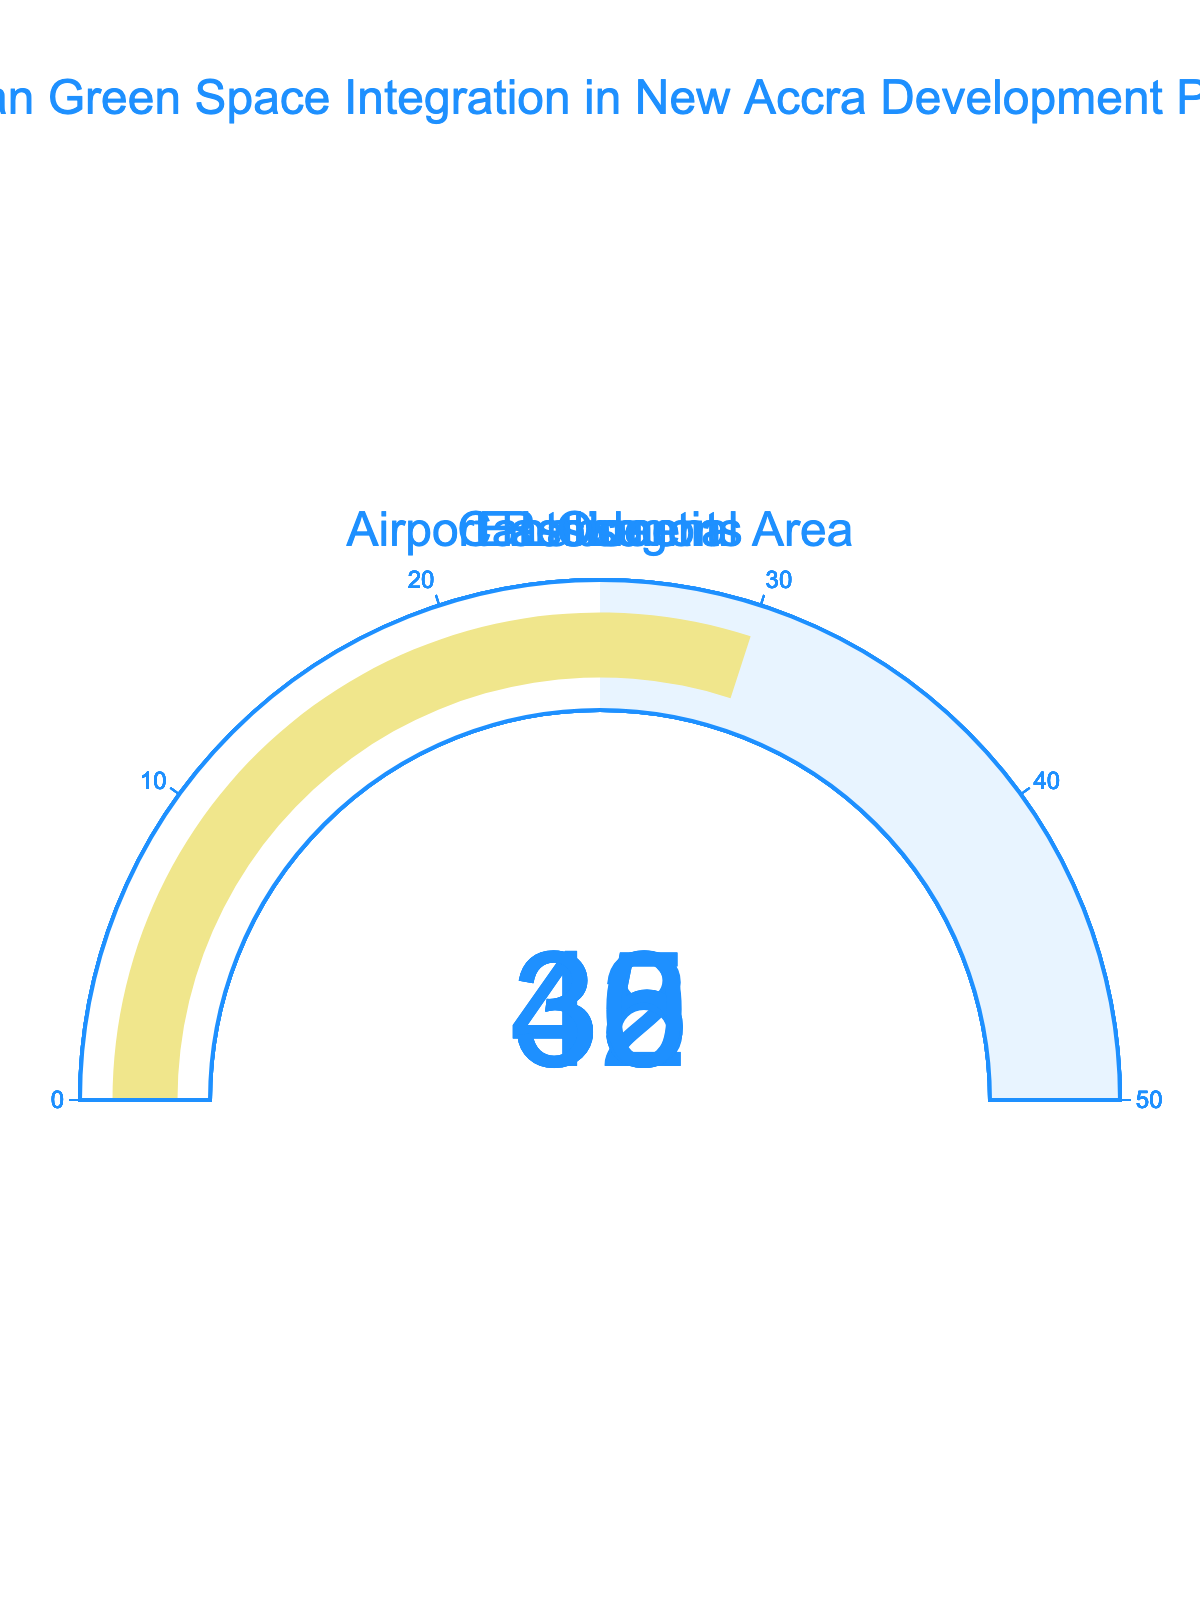What is the integration rate for the Cantonments area? The gauge chart for the Cantonments area shows the integration rate as 42.
Answer: 42 How does the integration rate of Osu compare with that of Airport Residential Area? The gauge chart shows that Osu has an integration rate of 30, while the Airport Residential Area has a rate of 45. Therefore, the integration rate of Osu is lower.
Answer: Osu's rate is lower Which location has the highest integration rate? By inspecting the gauge charts, the Airport Residential Area has the highest integration rate at 45.
Answer: Airport Residential Area Calculate the average integration rate across all locations. The integration rates are 42, 38, 45, 35, and 30. Summing them gives 190. Dividing by 5 (the number of locations) results in an average of 38.
Answer: 38 What is the difference between the highest and lowest integration rates? The highest rate is 45 (Airport Residential Area) and the lowest is 30 (Osu). The difference is 45 - 30 = 15.
Answer: 15 Is there any area with an integration rate below 35? Yes, Osu has an integration rate of 30, which is below 35.
Answer: Yes What can you infer about the overall trend in integration rates from the locations shown? Reviewing the gauge charts, the integration rates range from 30 to 45, indicating a moderate effort in integrating green spaces in these areas. However, none of the locations have reached the maximum of 50, implying room for improvement.
Answer: Moderate effort, room for improvement If you were to place the locations in descending order of their integration rates, what would be the sequence? The rates are 45, 42, 38, 35, and 30. Placing them in descending order gives: Airport Residential Area, Cantonments, East Legon, Labone, and Osu.
Answer: Airport Residential Area, Cantonments, East Legon, Labone, Osu Which two areas have the most similar integration rates? Cantonments (42) and East Legon (38) are the closest in integration rates, with a difference of 4.
Answer: Cantonments and East Legon For which location is the integration rate closest to the median value of the dataset? The sorted rates are 30, 35, 38, 42, and 45. The median value is 38, and East Legon has this rate.
Answer: East Legon 